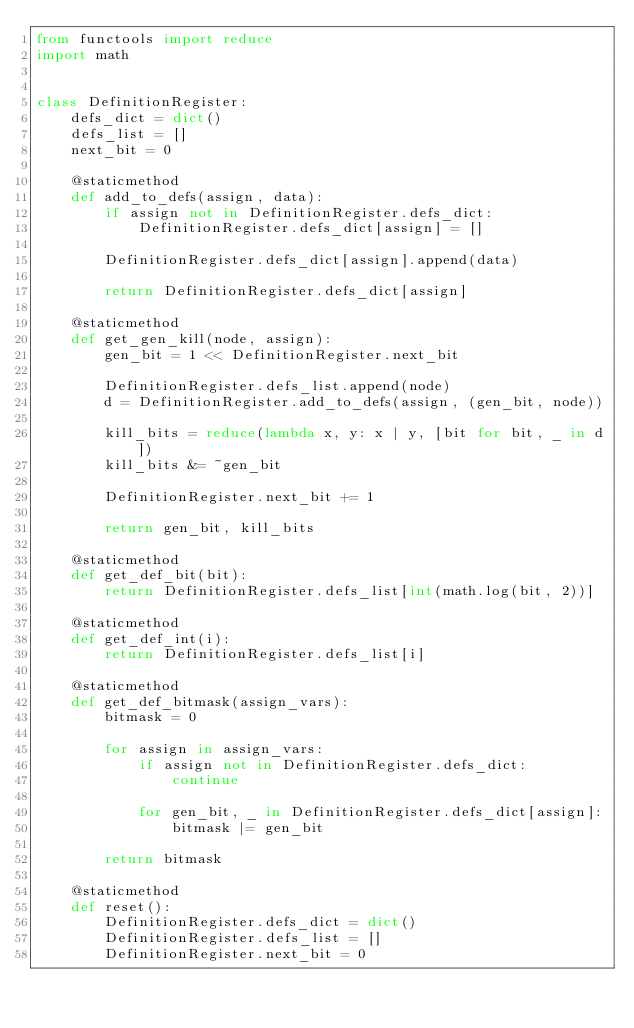Convert code to text. <code><loc_0><loc_0><loc_500><loc_500><_Python_>from functools import reduce
import math


class DefinitionRegister:
    defs_dict = dict()
    defs_list = []
    next_bit = 0

    @staticmethod
    def add_to_defs(assign, data):
        if assign not in DefinitionRegister.defs_dict:
            DefinitionRegister.defs_dict[assign] = []

        DefinitionRegister.defs_dict[assign].append(data)

        return DefinitionRegister.defs_dict[assign]

    @staticmethod
    def get_gen_kill(node, assign):
        gen_bit = 1 << DefinitionRegister.next_bit

        DefinitionRegister.defs_list.append(node)
        d = DefinitionRegister.add_to_defs(assign, (gen_bit, node))

        kill_bits = reduce(lambda x, y: x | y, [bit for bit, _ in d])
        kill_bits &= ~gen_bit

        DefinitionRegister.next_bit += 1

        return gen_bit, kill_bits

    @staticmethod
    def get_def_bit(bit):
        return DefinitionRegister.defs_list[int(math.log(bit, 2))]

    @staticmethod
    def get_def_int(i):
        return DefinitionRegister.defs_list[i]

    @staticmethod
    def get_def_bitmask(assign_vars):
        bitmask = 0

        for assign in assign_vars:
            if assign not in DefinitionRegister.defs_dict:
                continue

            for gen_bit, _ in DefinitionRegister.defs_dict[assign]:
                bitmask |= gen_bit

        return bitmask

    @staticmethod
    def reset():
        DefinitionRegister.defs_dict = dict()
        DefinitionRegister.defs_list = []
        DefinitionRegister.next_bit = 0


</code> 